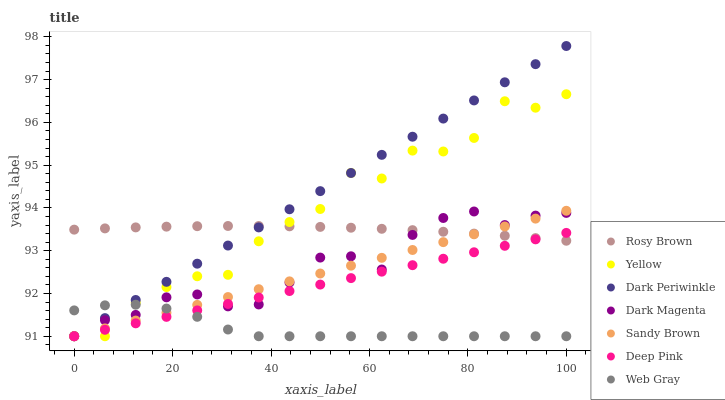Does Web Gray have the minimum area under the curve?
Answer yes or no. Yes. Does Dark Periwinkle have the maximum area under the curve?
Answer yes or no. Yes. Does Dark Magenta have the minimum area under the curve?
Answer yes or no. No. Does Dark Magenta have the maximum area under the curve?
Answer yes or no. No. Is Deep Pink the smoothest?
Answer yes or no. Yes. Is Yellow the roughest?
Answer yes or no. Yes. Is Dark Magenta the smoothest?
Answer yes or no. No. Is Dark Magenta the roughest?
Answer yes or no. No. Does Deep Pink have the lowest value?
Answer yes or no. Yes. Does Rosy Brown have the lowest value?
Answer yes or no. No. Does Dark Periwinkle have the highest value?
Answer yes or no. Yes. Does Dark Magenta have the highest value?
Answer yes or no. No. Is Web Gray less than Rosy Brown?
Answer yes or no. Yes. Is Rosy Brown greater than Web Gray?
Answer yes or no. Yes. Does Web Gray intersect Yellow?
Answer yes or no. Yes. Is Web Gray less than Yellow?
Answer yes or no. No. Is Web Gray greater than Yellow?
Answer yes or no. No. Does Web Gray intersect Rosy Brown?
Answer yes or no. No. 